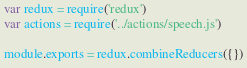Convert code to text. <code><loc_0><loc_0><loc_500><loc_500><_JavaScript_>var redux = require('redux')
var actions = require('../actions/speech.js')

module.exports = redux.combineReducers({})
</code> 